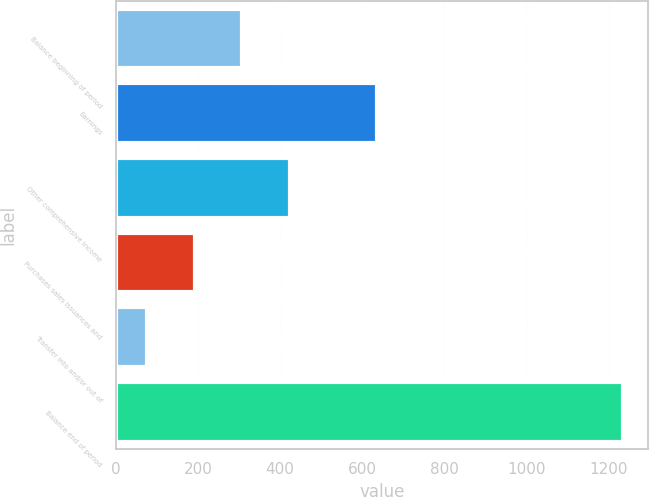Convert chart. <chart><loc_0><loc_0><loc_500><loc_500><bar_chart><fcel>Balance beginning of period<fcel>Earnings<fcel>Other comprehensive income<fcel>Purchases sales issuances and<fcel>Transfer into and/or out of<fcel>Balance end of period<nl><fcel>307.6<fcel>637<fcel>423.4<fcel>191.8<fcel>76<fcel>1234<nl></chart> 